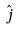<formula> <loc_0><loc_0><loc_500><loc_500>\hat { j }</formula> 